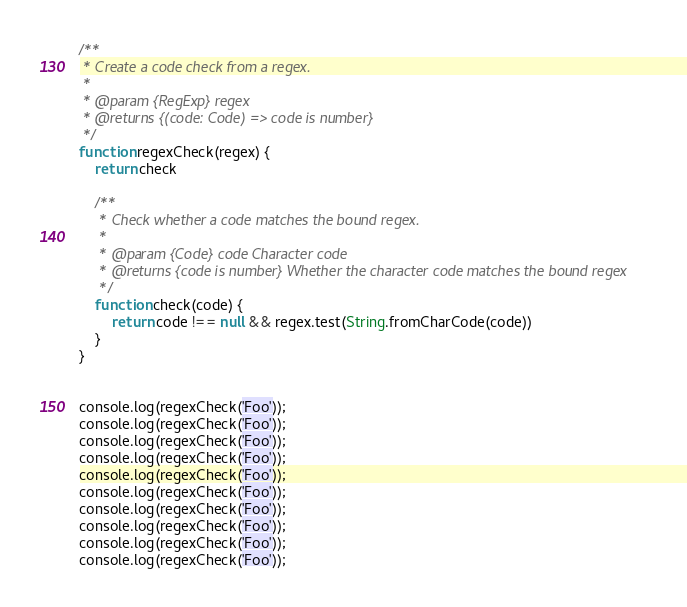<code> <loc_0><loc_0><loc_500><loc_500><_JavaScript_>/**
 * Create a code check from a regex.
 *
 * @param {RegExp} regex
 * @returns {(code: Code) => code is number}
 */
function regexCheck(regex) {
    return check

    /**
     * Check whether a code matches the bound regex.
     *
     * @param {Code} code Character code
     * @returns {code is number} Whether the character code matches the bound regex
     */
    function check(code) {
        return code !== null && regex.test(String.fromCharCode(code))
    }
}


console.log(regexCheck('Foo'));
console.log(regexCheck('Foo'));
console.log(regexCheck('Foo'));
console.log(regexCheck('Foo'));
console.log(regexCheck('Foo'));
console.log(regexCheck('Foo'));
console.log(regexCheck('Foo'));
console.log(regexCheck('Foo'));
console.log(regexCheck('Foo'));
console.log(regexCheck('Foo'));</code> 